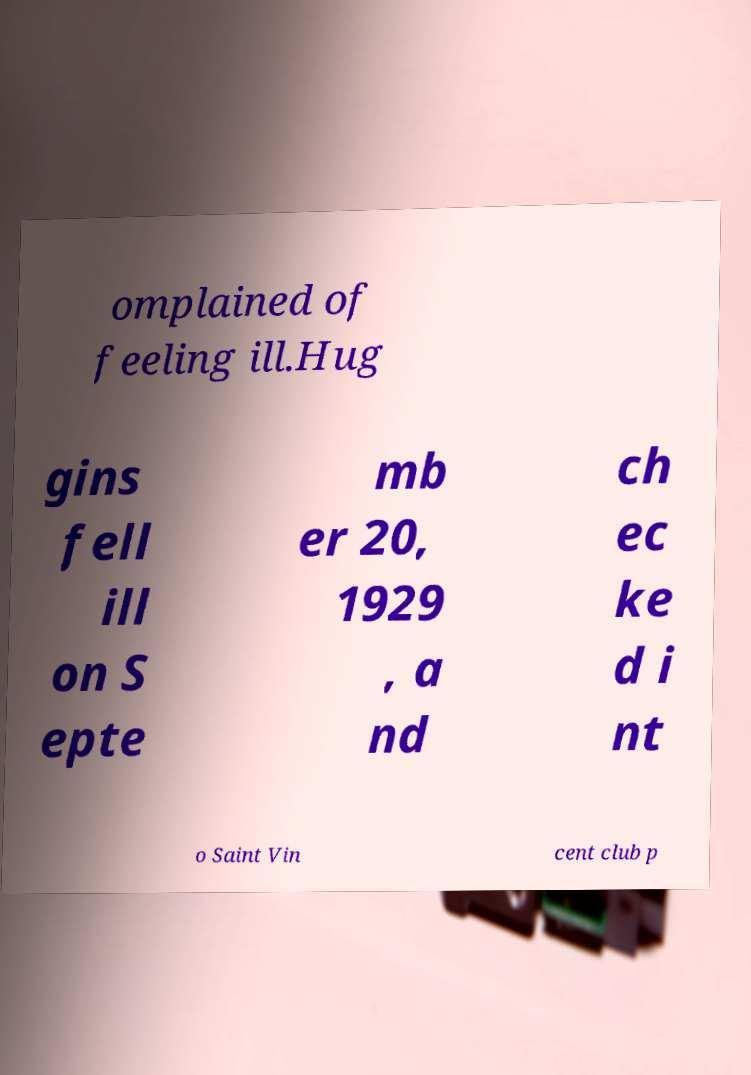Could you extract and type out the text from this image? omplained of feeling ill.Hug gins fell ill on S epte mb er 20, 1929 , a nd ch ec ke d i nt o Saint Vin cent club p 